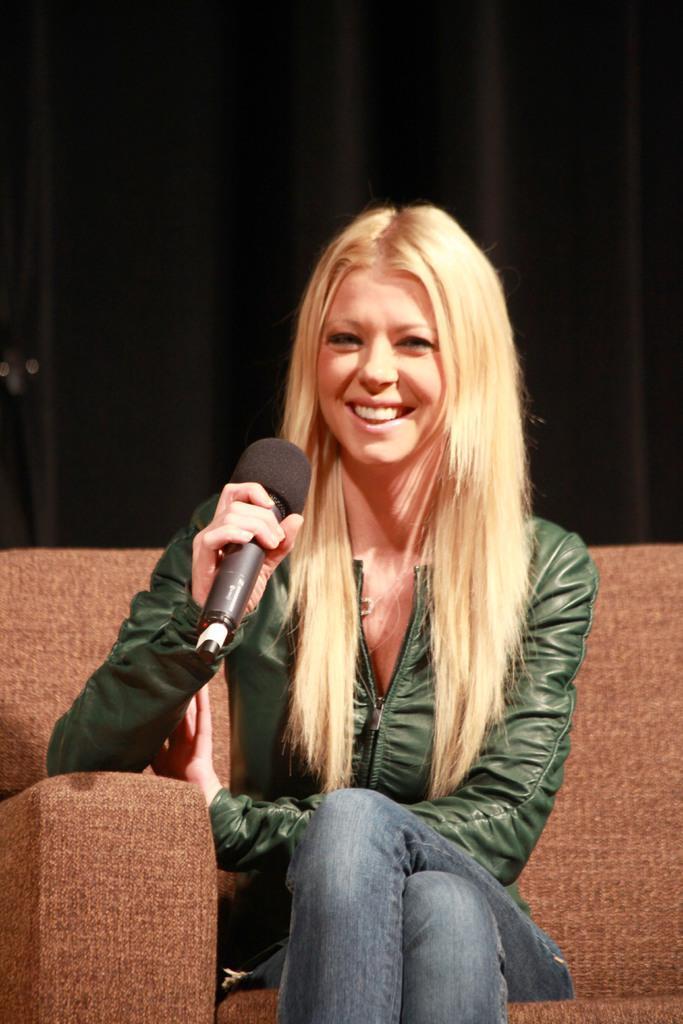How would you summarize this image in a sentence or two? In the image there is a woman with blond hair sat on sofa holding a mic. She is smiling. 